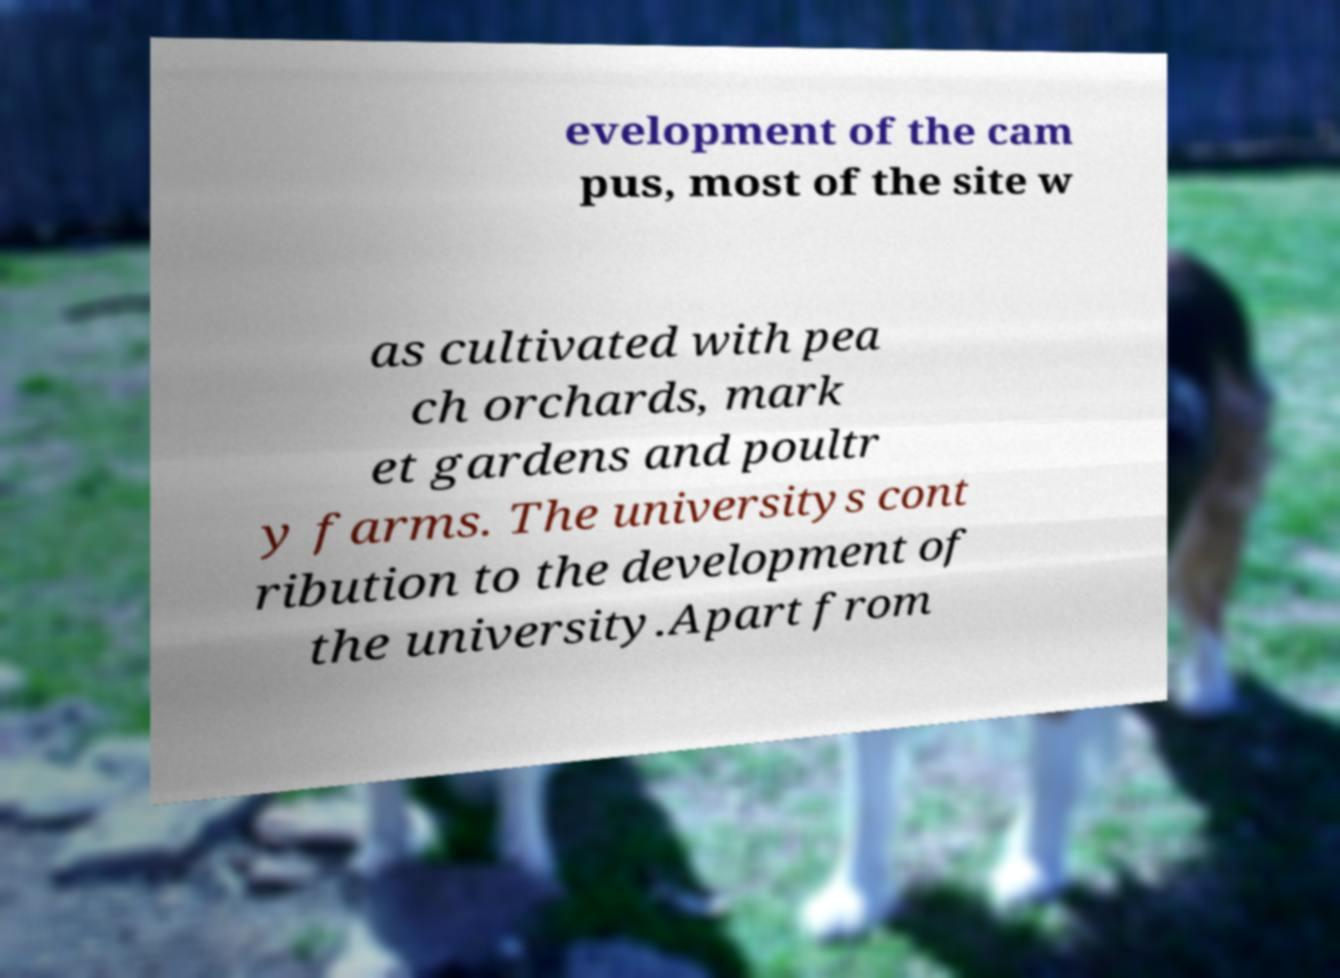There's text embedded in this image that I need extracted. Can you transcribe it verbatim? evelopment of the cam pus, most of the site w as cultivated with pea ch orchards, mark et gardens and poultr y farms. The universitys cont ribution to the development of the university.Apart from 